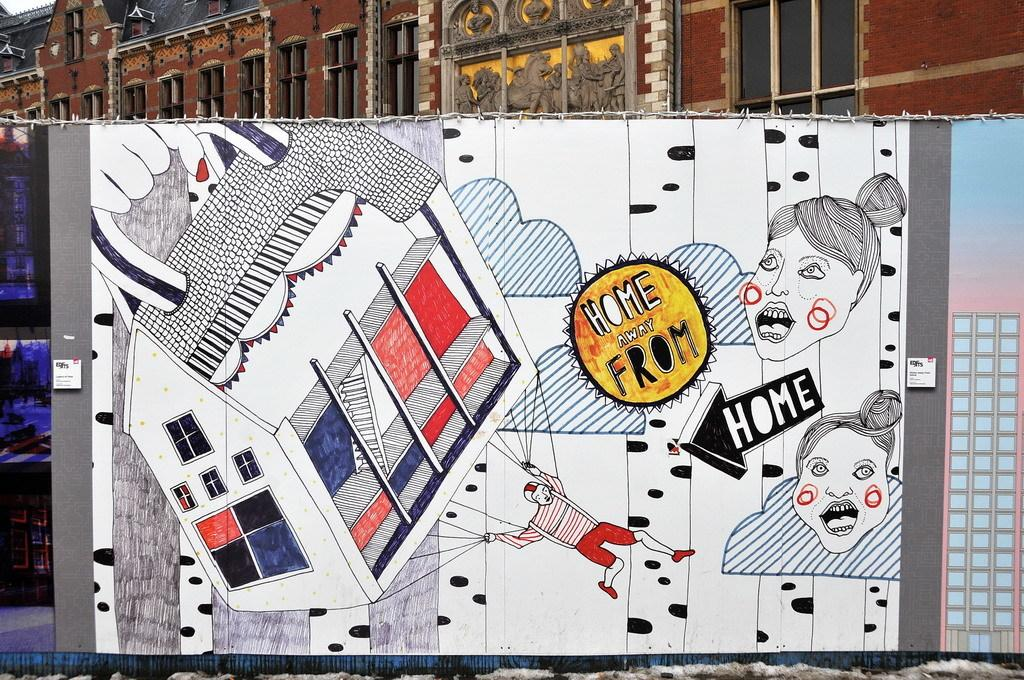What type of board is present in the image? There is a cartoon board in the image. What is depicted on the cartoon board? The cartoon board features a person's face and a house. What can be seen in the background of the image? There is a building in the background of the image. What part of the sky is visible in the image? The sky is visible in the top left corner of the image. What type of stew is being cooked in the image? There is no stew present in the image; it features a cartoon board with a person's face and a house. 